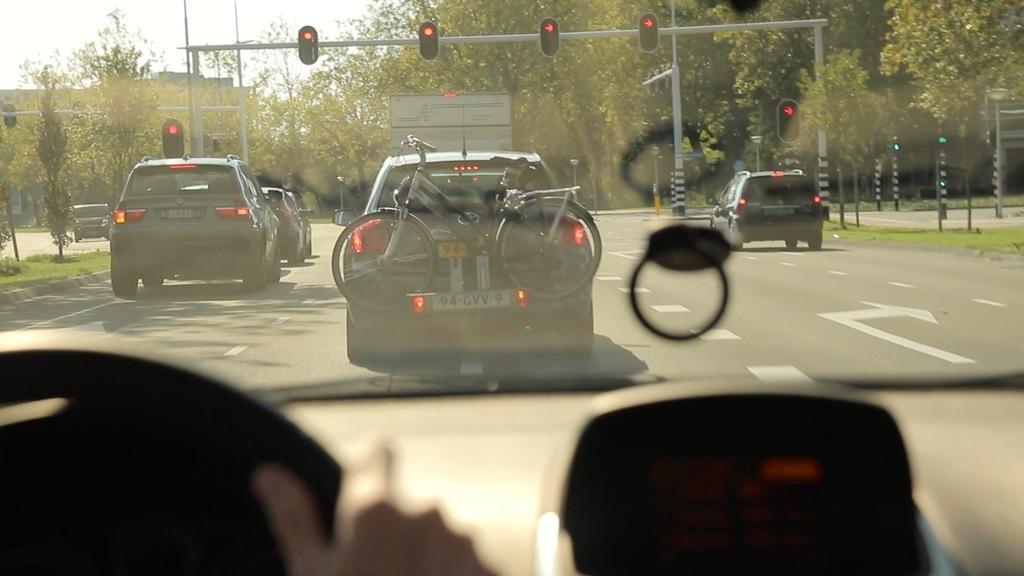Describe this image in one or two sentences. In this image I see the inside view of the vehicle and I see the steering over here and I see a person's fingers on it and through the glass I see the road on which there are number of cars and I see the cycle over here and I see the poles on which there are traffic signals and I see the green grass and I see number of trees and in the background I see the sky. 